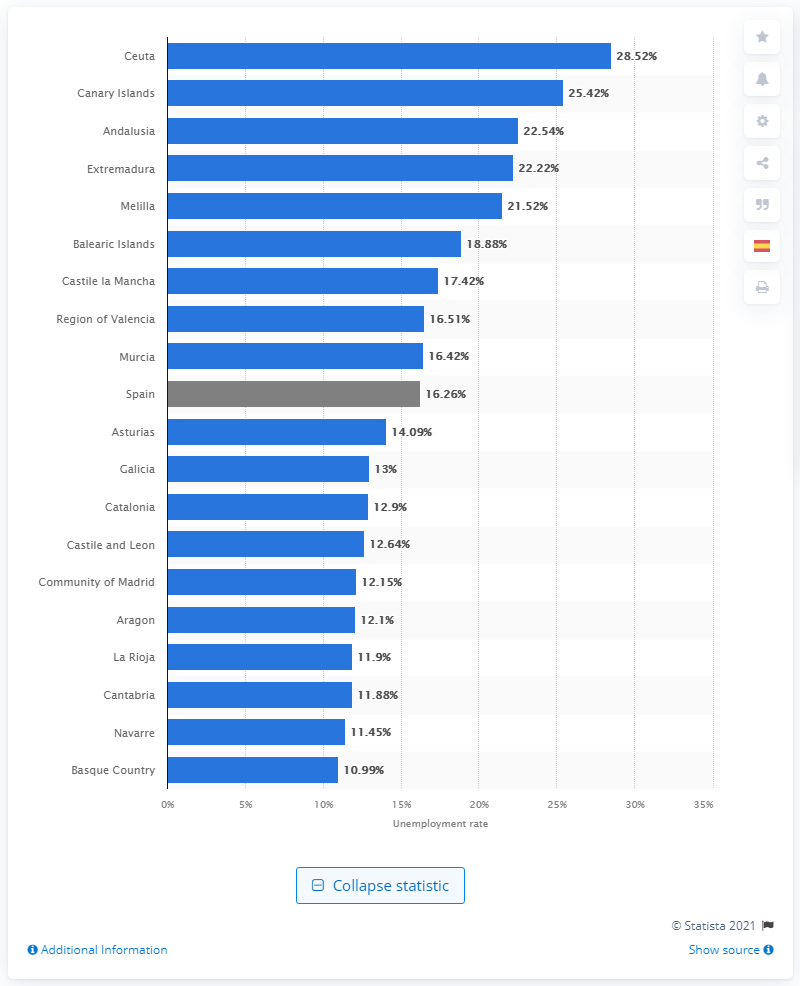What is the region with the highest unemployment rate according to the image? The region with the highest unemployment rate in Spain as shown in the image is Ceuta, which stands out with an unemployment rate of 28.52%. 